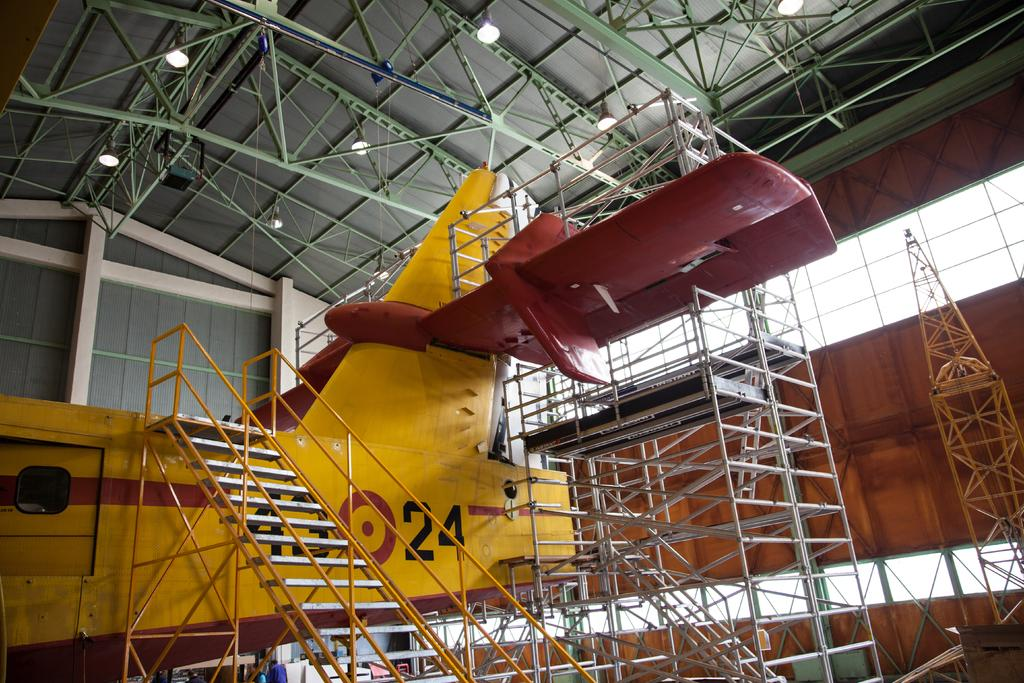Provide a one-sentence caption for the provided image. A yellow and maroon with the number 24 on the side. 